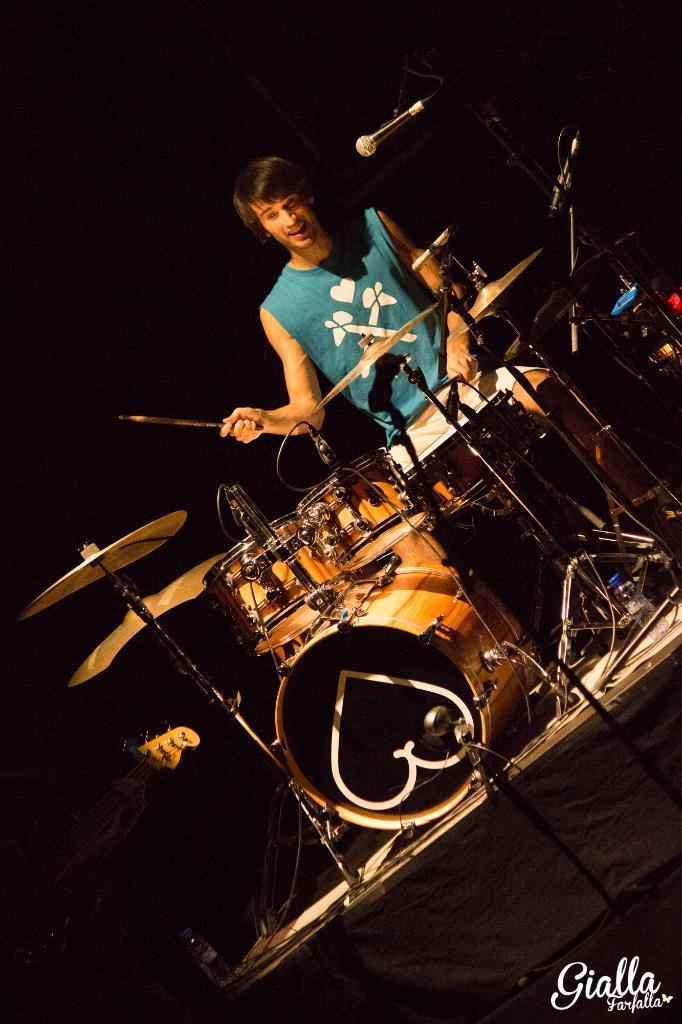In one or two sentences, can you explain what this image depicts? This is the picture of a person in blue shirt standing in front of a musical instrument set and playing it. 